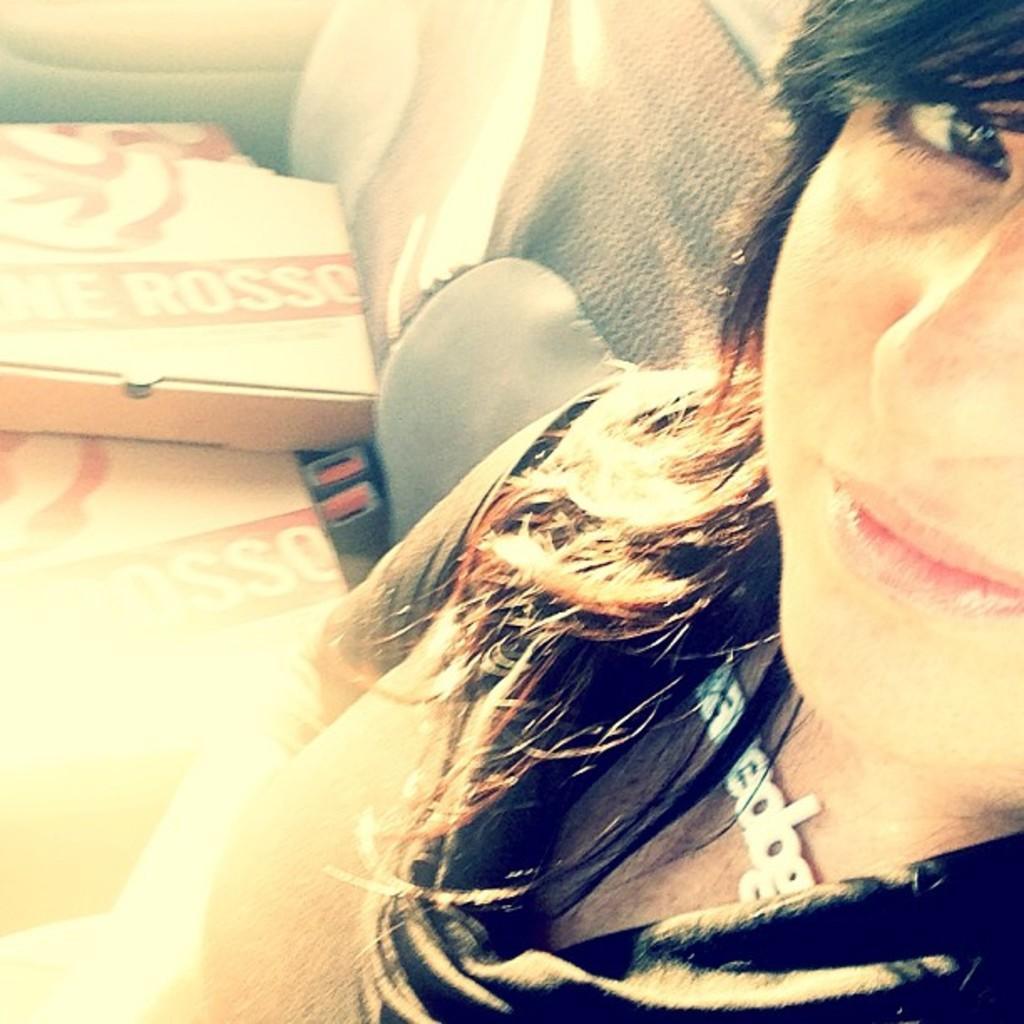How would you summarize this image in a sentence or two? In this image I can see a person is sitting inside the vehicle. I can see few boxes on the seat of the vehicle. 